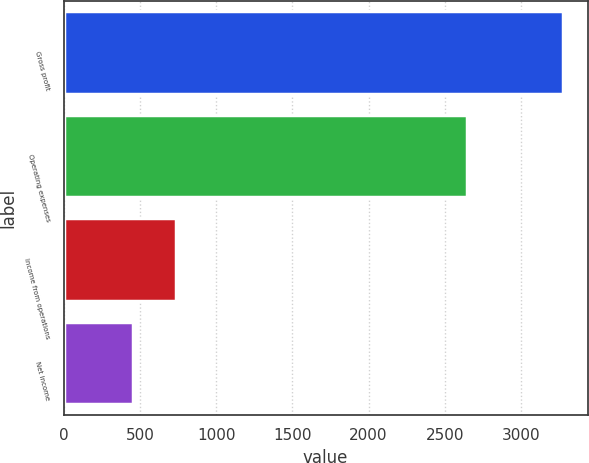Convert chart. <chart><loc_0><loc_0><loc_500><loc_500><bar_chart><fcel>Gross profit<fcel>Operating expenses<fcel>Income from operations<fcel>Net income<nl><fcel>3274<fcel>2648<fcel>737.8<fcel>456<nl></chart> 